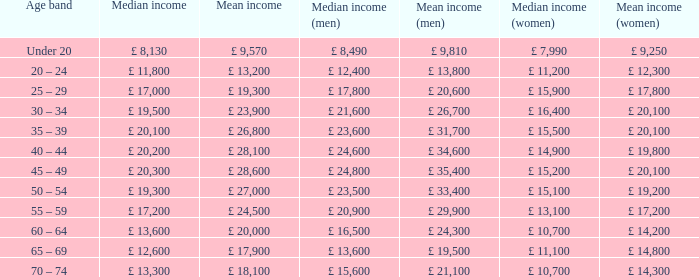Identify the middle income for people in the age group below 20. £ 8,130. 